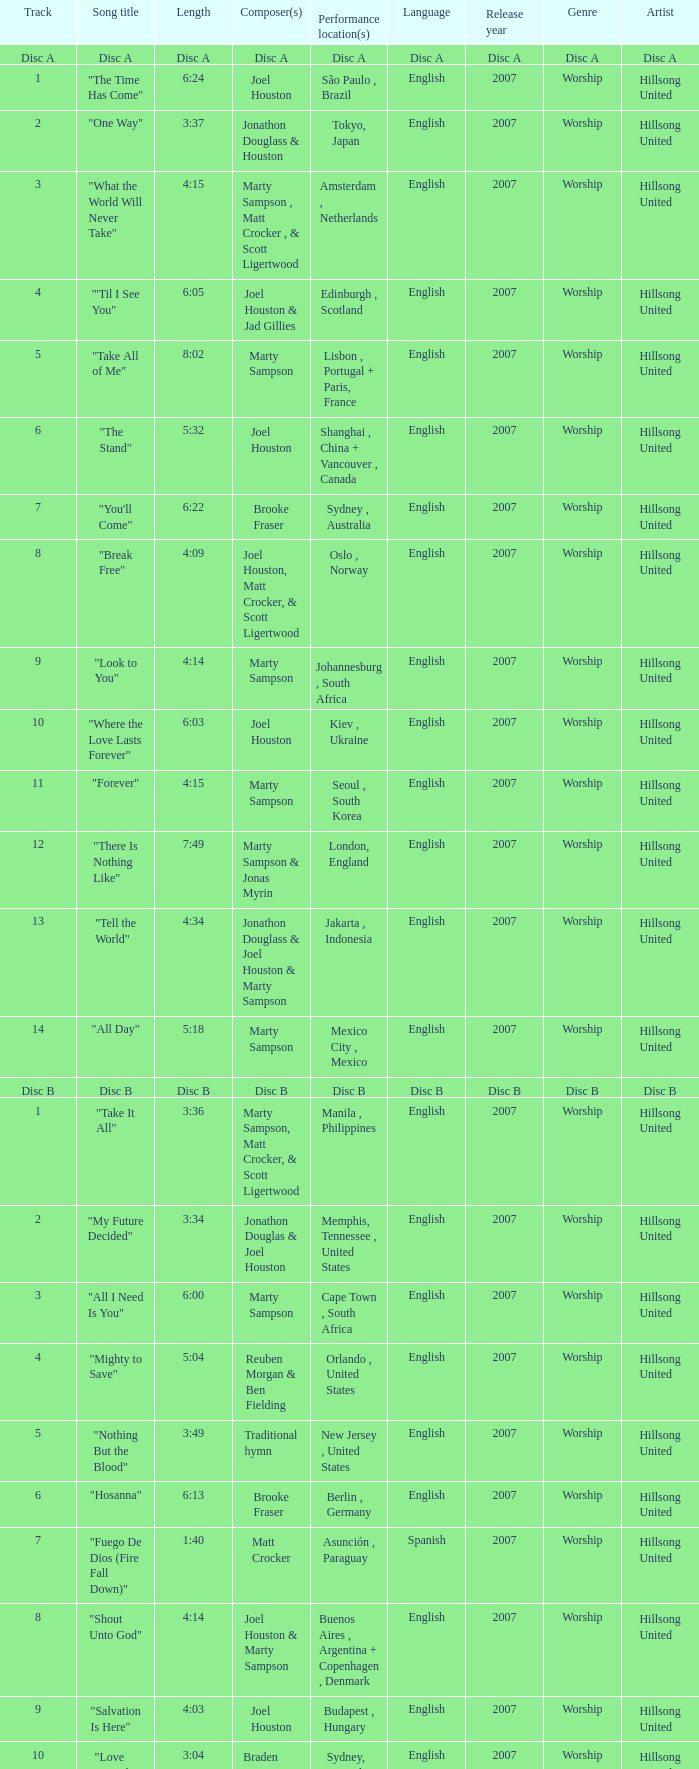What is the lengtho f track 16? 5:55. 